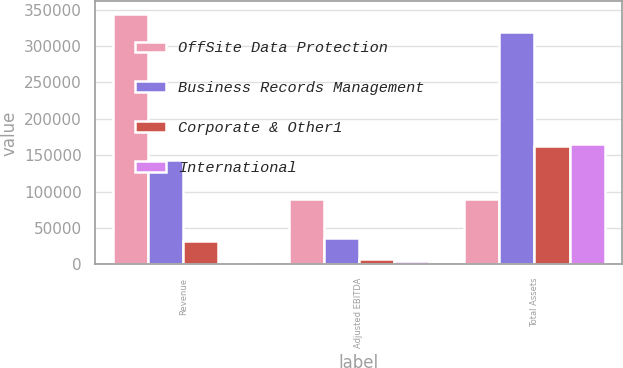Convert chart. <chart><loc_0><loc_0><loc_500><loc_500><stacked_bar_chart><ecel><fcel>Revenue<fcel>Adjusted EBITDA<fcel>Total Assets<nl><fcel>OffSite Data Protection<fcel>343969<fcel>90018<fcel>90018<nl><fcel>Business Records Management<fcel>143057<fcel>36975<fcel>319416<nl><fcel>Corporate & Other1<fcel>31618<fcel>7348<fcel>163174<nl><fcel>International<fcel>905<fcel>4670<fcel>166067<nl></chart> 